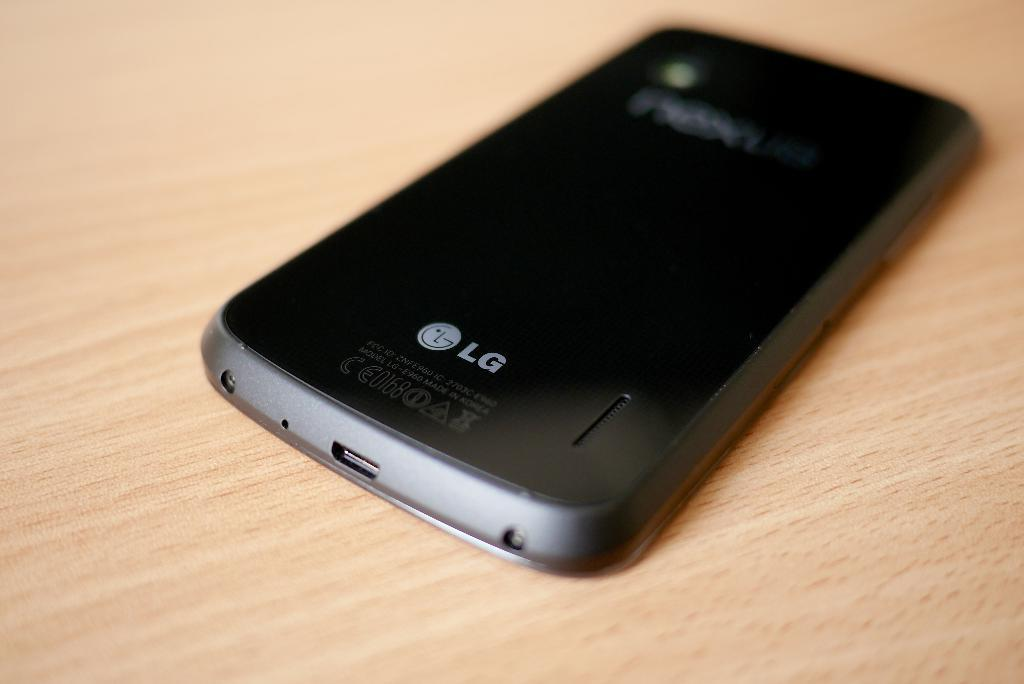<image>
Render a clear and concise summary of the photo. A black phone on a wooden table made by LG. 